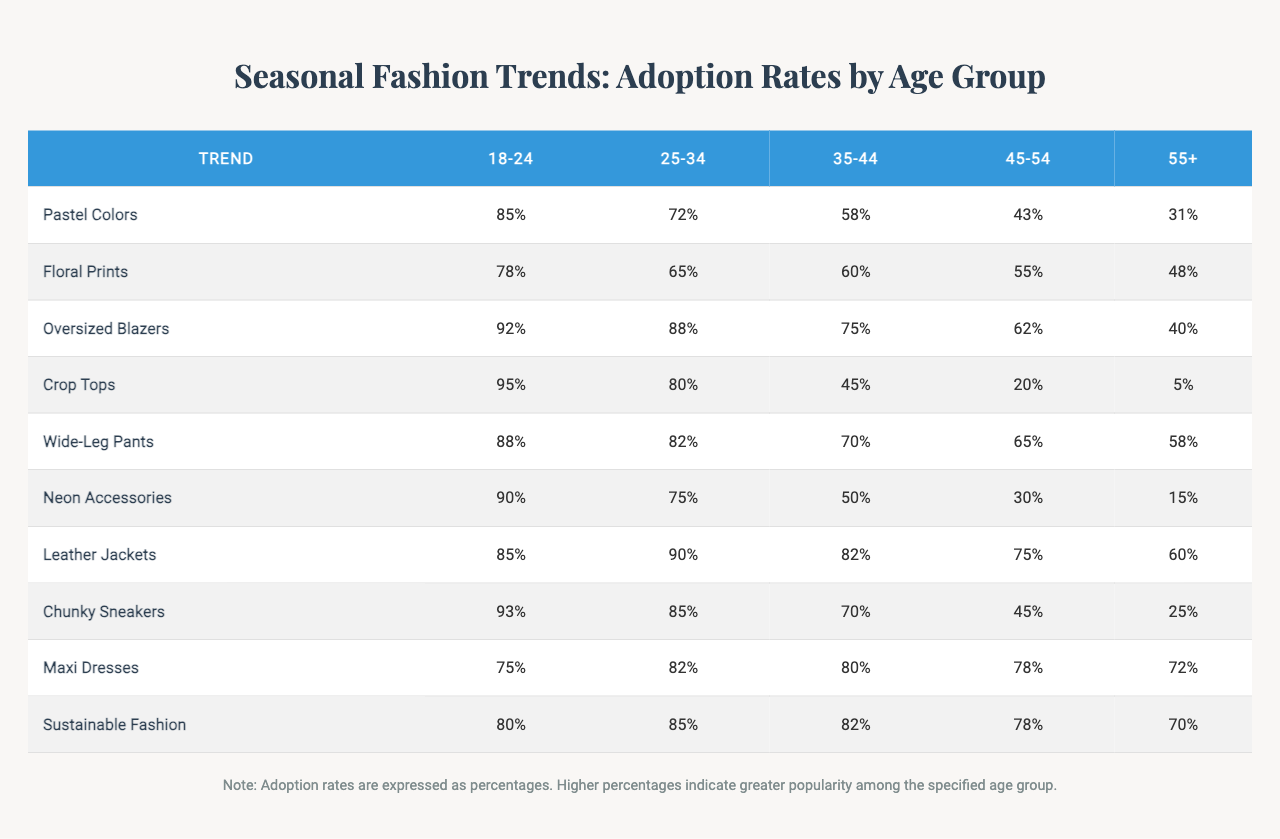What is the highest adoption rate trend among the 18-24 age group? In the 18-24 age group, the adoption rates are 85% for Pastel Colors, 78% for Floral Prints, 92% for Oversized Blazers, 95% for Crop Tops, 88% for Wide-Leg Pants, 90% for Neon Accessories, 85% for Leather Jackets, 93% for Chunky Sneakers, 75% for Maxi Dresses, and 80% for Sustainable Fashion. The highest rate is 95% for Crop Tops.
Answer: 95% Which age group has the lowest adoption rate for Floral Prints? The adoption rate for Floral Prints is 78% for the 18-24 age group, 65% for the 25-34 age group, 60% for the 35-44 age group, 55% for the 45-54 age group, and 48% for the 55+ age group. The lowest adoption rate is 48% for the 55+ age group.
Answer: 55+ What is the average adoption rate of Sustainable Fashion across all age groups? The adoption rates for Sustainable Fashion are 80%, 85%, 82%, 78%, and 70%. Summing them gives 80 + 85 + 82 + 78 + 70 = 395. Dividing by 5 (the number of age groups) gives an average of 395 / 5 = 79.
Answer: 79% Is the adoption rate for Leather Jackets higher among the 25-34 age group than among the 35-44 age group? The adoption rate for Leather Jackets is 90% for the 25-34 age group and 82% for the 35-44 age group. Since 90% is higher than 82%, the statement is true.
Answer: Yes What is the difference in adoption rates for Chunky Sneakers between the 18-24 and 45-54 age groups? The adoption rate for Chunky Sneakers is 93% for the 18-24 age group and 45% for the 45-54 age group. The difference is calculated as 93 - 45 = 48.
Answer: 48% Among the trends listed, which one sees the least popularity among the 55+ age group? For the 55+ age group, the adoption rates are 31% for Pastel Colors, 48% for Floral Prints, 40% for Oversized Blazers, 5% for Crop Tops, 58% for Wide-Leg Pants, 15% for Neon Accessories, 60% for Leather Jackets, 25% for Chunky Sneakers, 72% for Maxi Dresses, and 70% for Sustainable Fashion. The lowest is 5% for Crop Tops.
Answer: Crop Tops Which trend has the highest overall average adoption rate across all age groups? To find the overall average for each trend, sum the adoption rates and divide by the number of age groups. For example, Pastel Colors: (85 + 72 + 58 + 43 + 31) / 5 = 57.8. Applying this across all trends, the averages are Pastel Colors 57.8%, Floral Prints 61.8%, Oversized Blazers 71.4%, Crop Tops 57%, Wide-Leg Pants 72.6%, Neon Accessories 52%, Leather Jackets 78%, Chunky Sneakers 61.4%, Maxi Dresses 77.4%, Sustainable Fashion 79%. The highest average is for Sustainable Fashion at 79%.
Answer: Sustainable Fashion What trends are more popular among the younger age group compared to Leather Jackets? Leather Jackets have an adoption rate of 85% for the 18-24 age group, 90% for the 25-34 age group, 82% for the 35-44 age group, 75% for the 45-54 age group, and 60% for the 55+ age group. In comparison, Pastel Colors (85% among 18-24), Oversized Blazers (92% among 18-24), Crop Tops (95% among 18-24), Wide-Leg Pants (88% among 18-24), and Neon Accessories (90% among 18-24) are all more popular among the younger age groups.
Answer: Pastel Colors, Oversized Blazers, Crop Tops, Wide-Leg Pants, Neon Accessories What percentage of the 35-44 age group adopted the trend of Maxi Dresses? The adoption rate for Maxi Dresses in the 35-44 age group is noted in the table as 80%.
Answer: 80% 